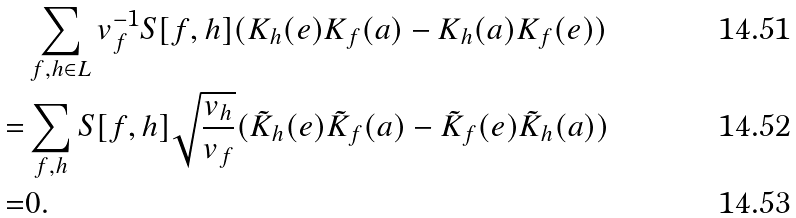Convert formula to latex. <formula><loc_0><loc_0><loc_500><loc_500>& \sum _ { f , h \in L } v _ { f } ^ { - 1 } S [ f , h ] ( K _ { h } ( e ) K _ { f } ( a ) - K _ { h } ( a ) K _ { f } ( e ) ) \\ = & \sum _ { f , h } S [ f , h ] \sqrt { \frac { v _ { h } } { v _ { f } } } ( \tilde { K } _ { h } ( e ) \tilde { K } _ { f } ( a ) - \tilde { K } _ { f } ( e ) \tilde { K } _ { h } ( a ) ) \\ = & 0 .</formula> 